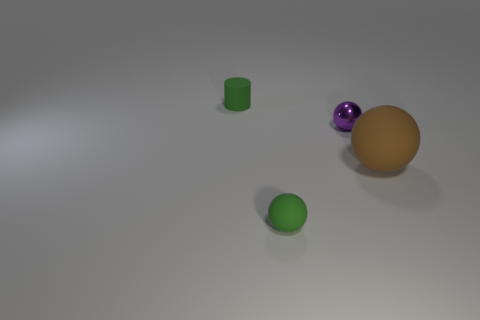Is there any other thing that has the same material as the small purple object?
Make the answer very short. No. How many small things are yellow blocks or green matte cylinders?
Make the answer very short. 1. What size is the cylinder?
Ensure brevity in your answer.  Small. Is the number of matte cylinders in front of the brown object greater than the number of purple things?
Provide a succinct answer. No. Is the number of small green cylinders that are in front of the tiny matte ball the same as the number of small purple balls behind the tiny green cylinder?
Make the answer very short. Yes. What is the color of the thing that is behind the large rubber ball and to the right of the green matte ball?
Offer a very short reply. Purple. Is there any other thing that is the same size as the green cylinder?
Make the answer very short. Yes. Is the number of tiny matte things to the left of the big brown rubber thing greater than the number of tiny things behind the tiny green rubber cylinder?
Give a very brief answer. Yes. Is the size of the rubber thing behind the brown matte sphere the same as the small green rubber ball?
Offer a very short reply. Yes. What number of tiny things are left of the small green thing on the left side of the green object in front of the purple thing?
Your answer should be compact. 0. 